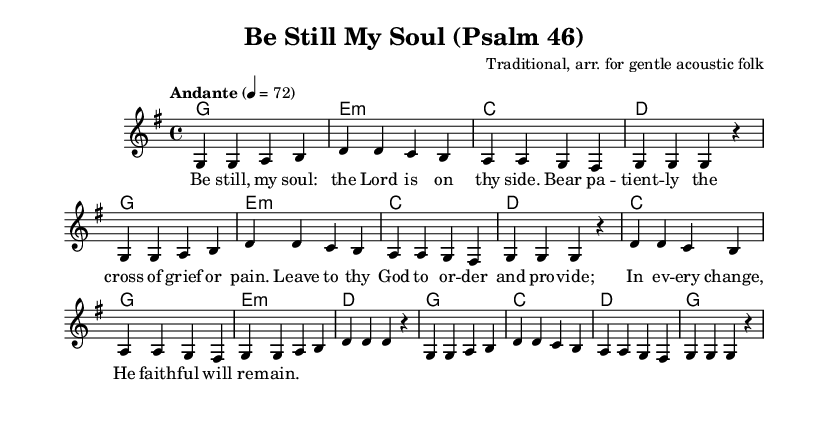What is the key signature of this music? The key signature is G major, which has one sharp (F#).
Answer: G major What is the time signature of this music? The time signature is indicated at the beginning and is 4/4, meaning there are four beats in each measure.
Answer: 4/4 What is the tempo marking for this piece? The tempo marking indicates "Andante," which suggests a moderate pace. The number indicates a metronome marking of 72 beats per minute.
Answer: Andante How many measures are in the music? Counting the measures in the sheet music shows there are 16 measures in total.
Answer: 16 What is the first word of the lyrics? The lyrics start with the words "Be still," which introduce the theme of the piece.
Answer: Be still Which chord is played in the first measure? The first measure contains the G major chord, indicated by the chord symbol at the top of that measure.
Answer: G How many lines are there in the lyrics? The lyrics have four lines, corresponding to the four phrases of the verse presented in the music.
Answer: 4 